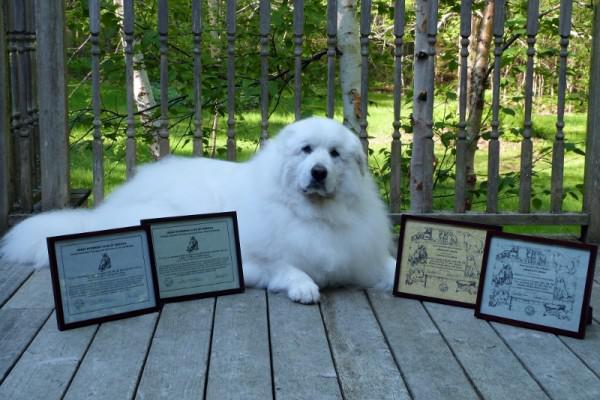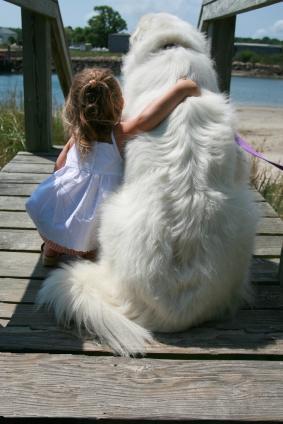The first image is the image on the left, the second image is the image on the right. Given the left and right images, does the statement "An image contains a large white dog laying down next to framed certificates." hold true? Answer yes or no. Yes. The first image is the image on the left, the second image is the image on the right. Analyze the images presented: Is the assertion "In one of the images, a white dog is laying down behind at least three framed documents." valid? Answer yes or no. Yes. 